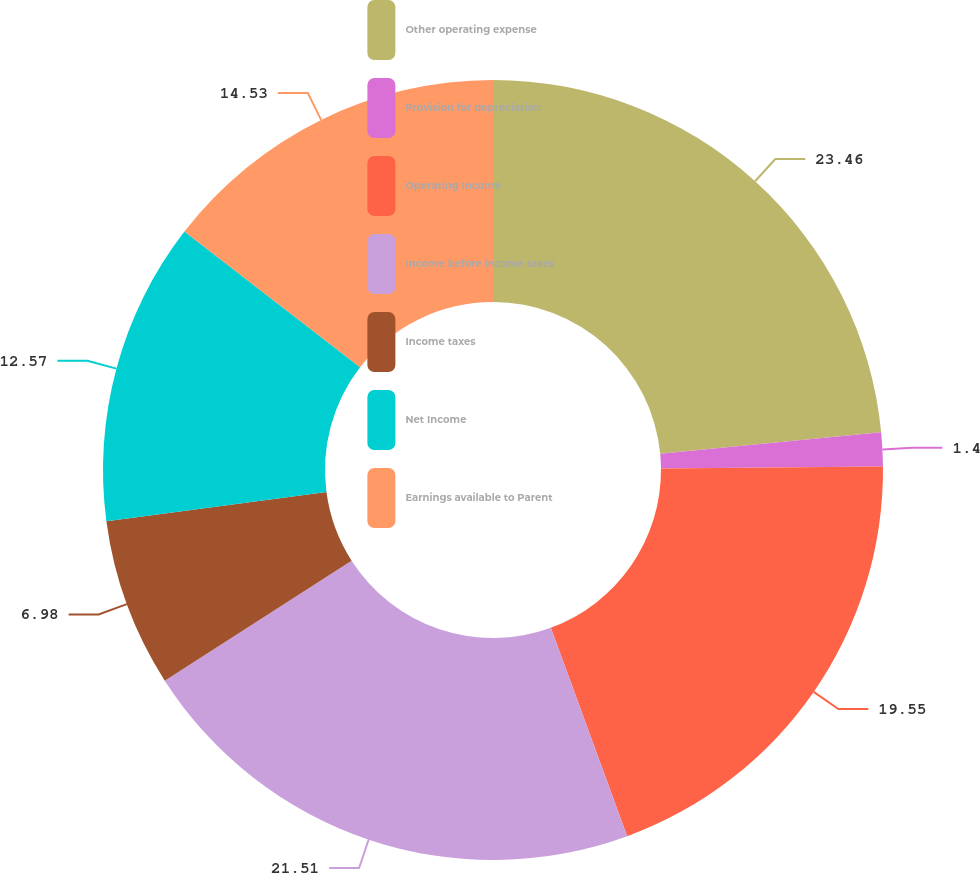<chart> <loc_0><loc_0><loc_500><loc_500><pie_chart><fcel>Other operating expense<fcel>Provision for depreciation<fcel>Operating Income<fcel>Income before income taxes<fcel>Income taxes<fcel>Net Income<fcel>Earnings available to Parent<nl><fcel>23.46%<fcel>1.4%<fcel>19.55%<fcel>21.51%<fcel>6.98%<fcel>12.57%<fcel>14.53%<nl></chart> 